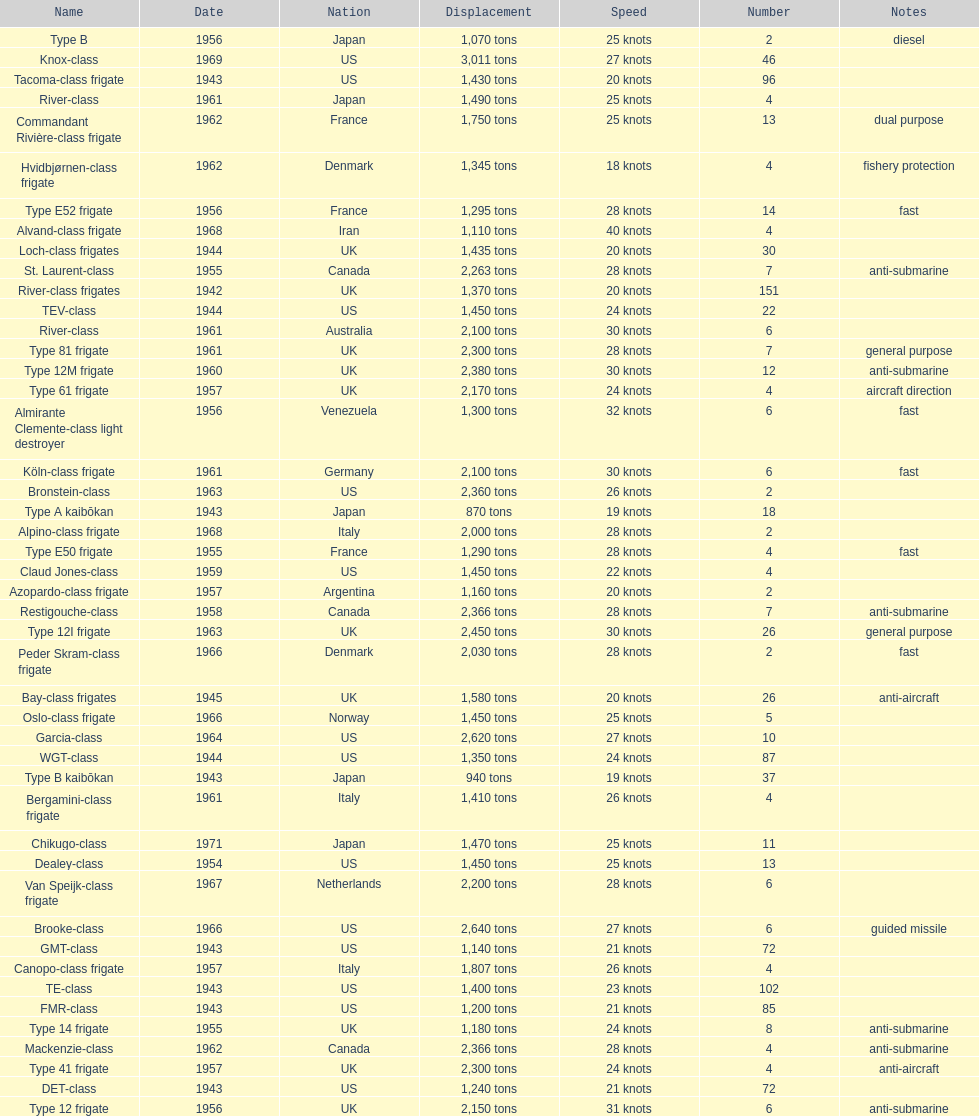What is the displacement in tons of the te-class? 1,400 tons. 